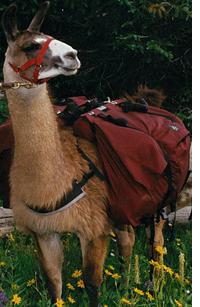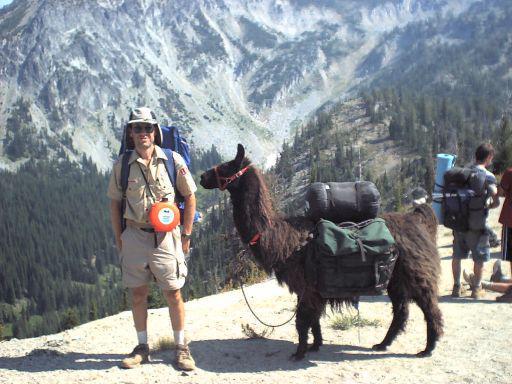The first image is the image on the left, the second image is the image on the right. Given the left and right images, does the statement "In one image, a single person is posing to the left of an alpaca." hold true? Answer yes or no. Yes. The first image is the image on the left, the second image is the image on the right. Given the left and right images, does the statement "In one image, exactly one forward-facing person in sunglasses is standing on an overlook next to the front-end of a llama with its body turned leftward." hold true? Answer yes or no. Yes. 